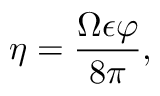Convert formula to latex. <formula><loc_0><loc_0><loc_500><loc_500>\eta = \frac { \Omega \epsilon \varphi } { 8 \pi } ,</formula> 